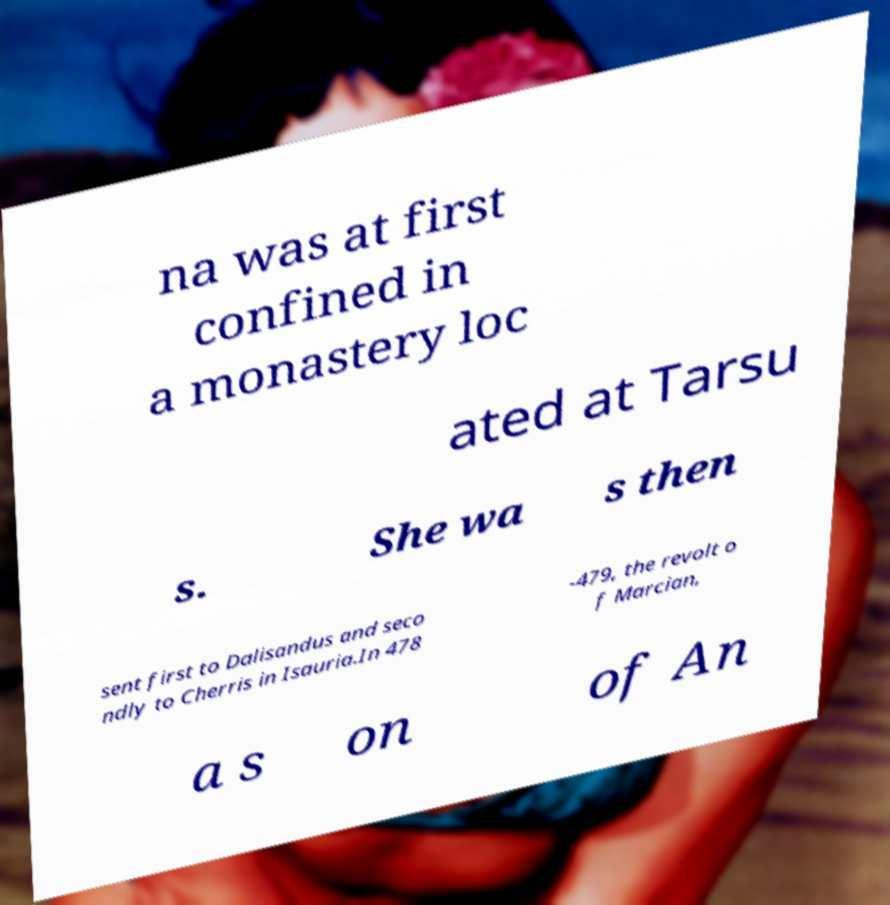Please identify and transcribe the text found in this image. na was at first confined in a monastery loc ated at Tarsu s. She wa s then sent first to Dalisandus and seco ndly to Cherris in Isauria.In 478 -479, the revolt o f Marcian, a s on of An 